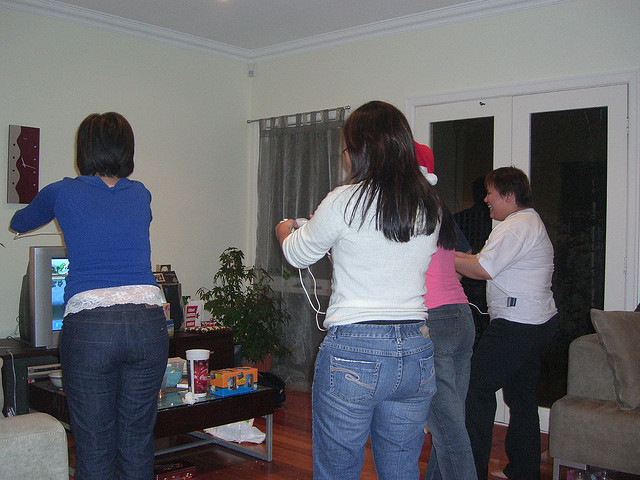What kind of emotions or mood does the image evoke? This scene exudes a sense of camaraderie and joy. The posture and engagement of the individuals suggest they are having a great time, surrounded by friends and immersed in fun, suggesting a mood of relaxation and enjoyment. 